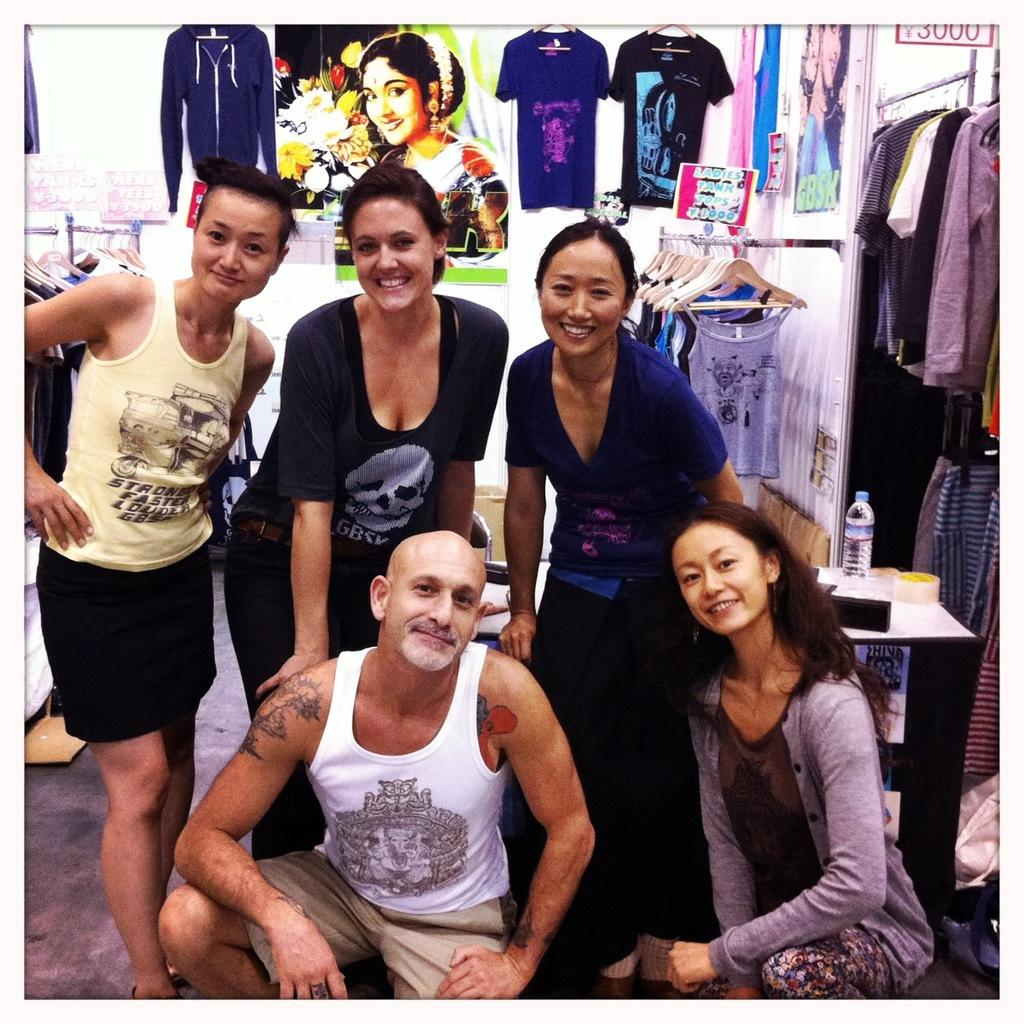What can be found in abundance in the room? There are many dresses in the room. What activity is taking place in the front of the room? A group of people are posing for a photo in the front of the room. What is visible in the background of the room? There is a wall in the background of the room. What decorations are on the wall? There are posters on the wall. What type of nail is being used to hang the posters on the wall? There is no mention of nails in the image, as the posters are simply on the wall. 